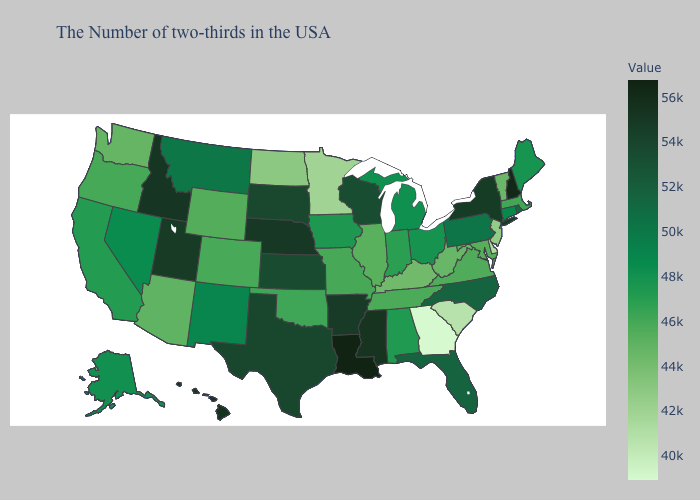Does Michigan have the highest value in the USA?
Give a very brief answer. No. Among the states that border Nebraska , which have the lowest value?
Keep it brief. Wyoming. Does Georgia have the lowest value in the South?
Concise answer only. Yes. Does the map have missing data?
Concise answer only. No. Does Montana have the highest value in the USA?
Keep it brief. No. Among the states that border Michigan , does Wisconsin have the highest value?
Give a very brief answer. Yes. Does Nevada have the highest value in the USA?
Keep it brief. No. 